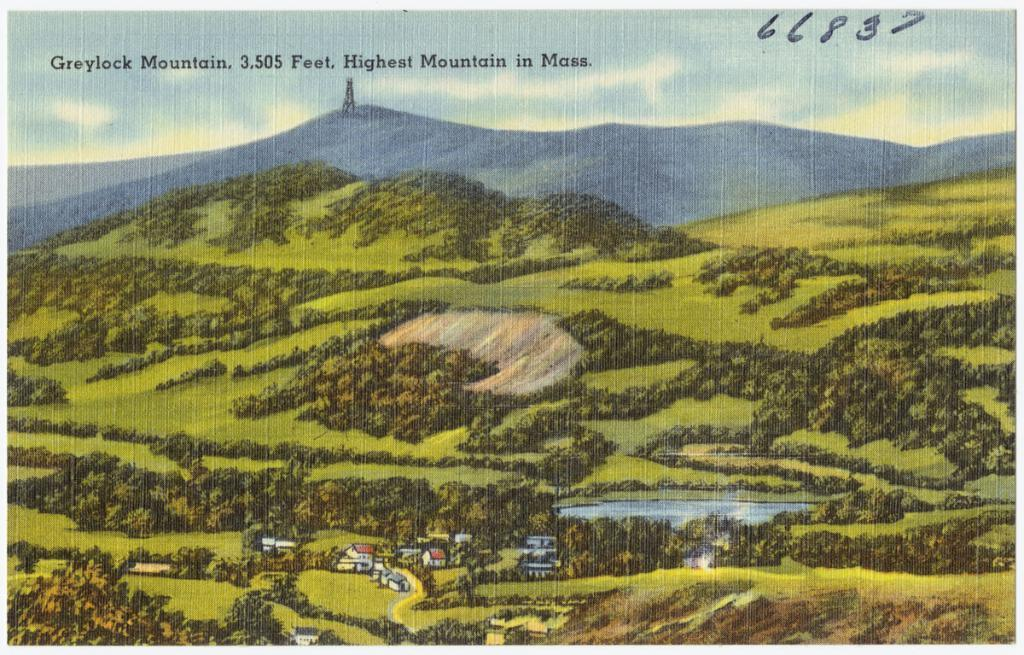What is the main subject of the image? There is a painting in the image. What is depicted on the grass surface in the painting? The painting depicts a grass surface with plants and houses. What body of water can be seen in the painting? There is a canal with water in the painting. What is visible in the sky in the painting? The sky with clouds is visible in the painting. What time of day is indicated by the agreement between the two parties in the image? There is no agreement between two parties present in the image, as it features a painting with various elements such as a grass surface, plants, houses, canal, and sky. 